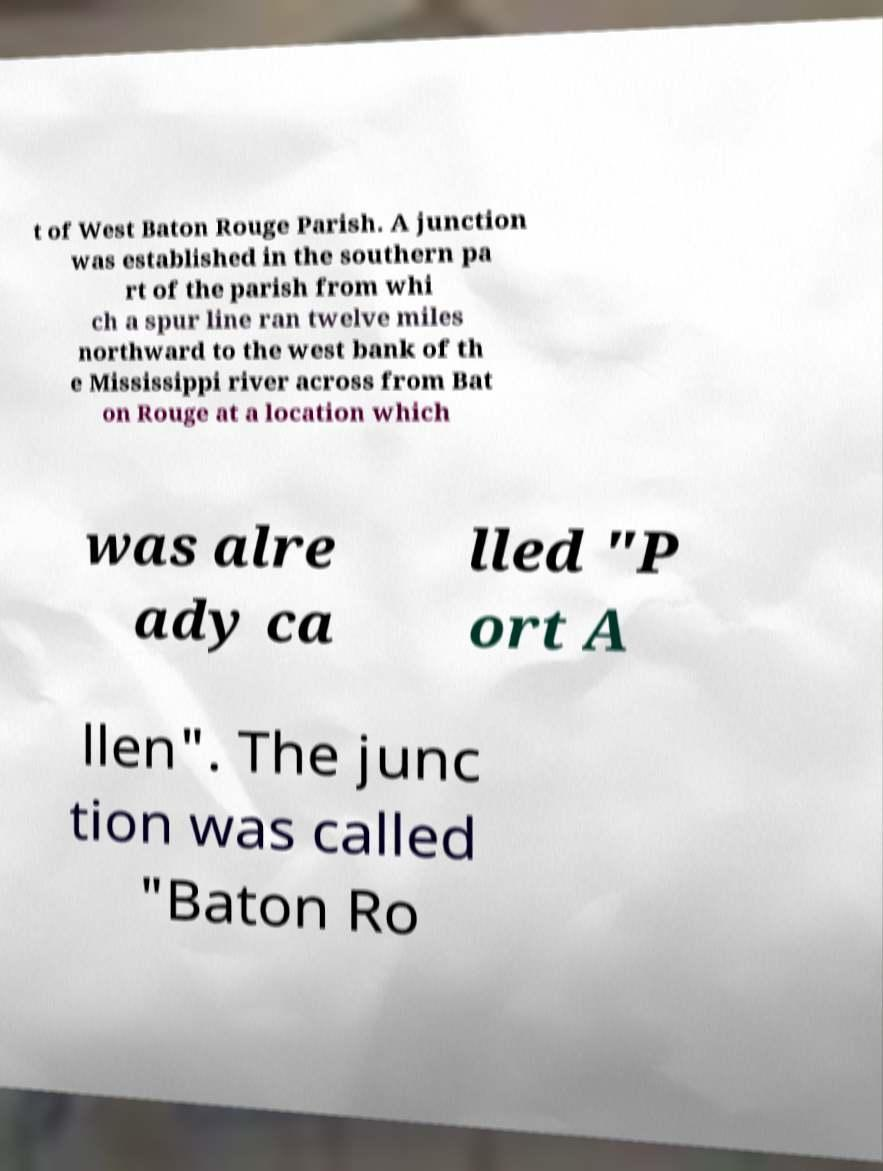Can you accurately transcribe the text from the provided image for me? t of West Baton Rouge Parish. A junction was established in the southern pa rt of the parish from whi ch a spur line ran twelve miles northward to the west bank of th e Mississippi river across from Bat on Rouge at a location which was alre ady ca lled "P ort A llen". The junc tion was called "Baton Ro 